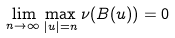<formula> <loc_0><loc_0><loc_500><loc_500>\lim _ { n \to \infty } \max _ { | u | = n } \nu ( B ( u ) ) = 0</formula> 